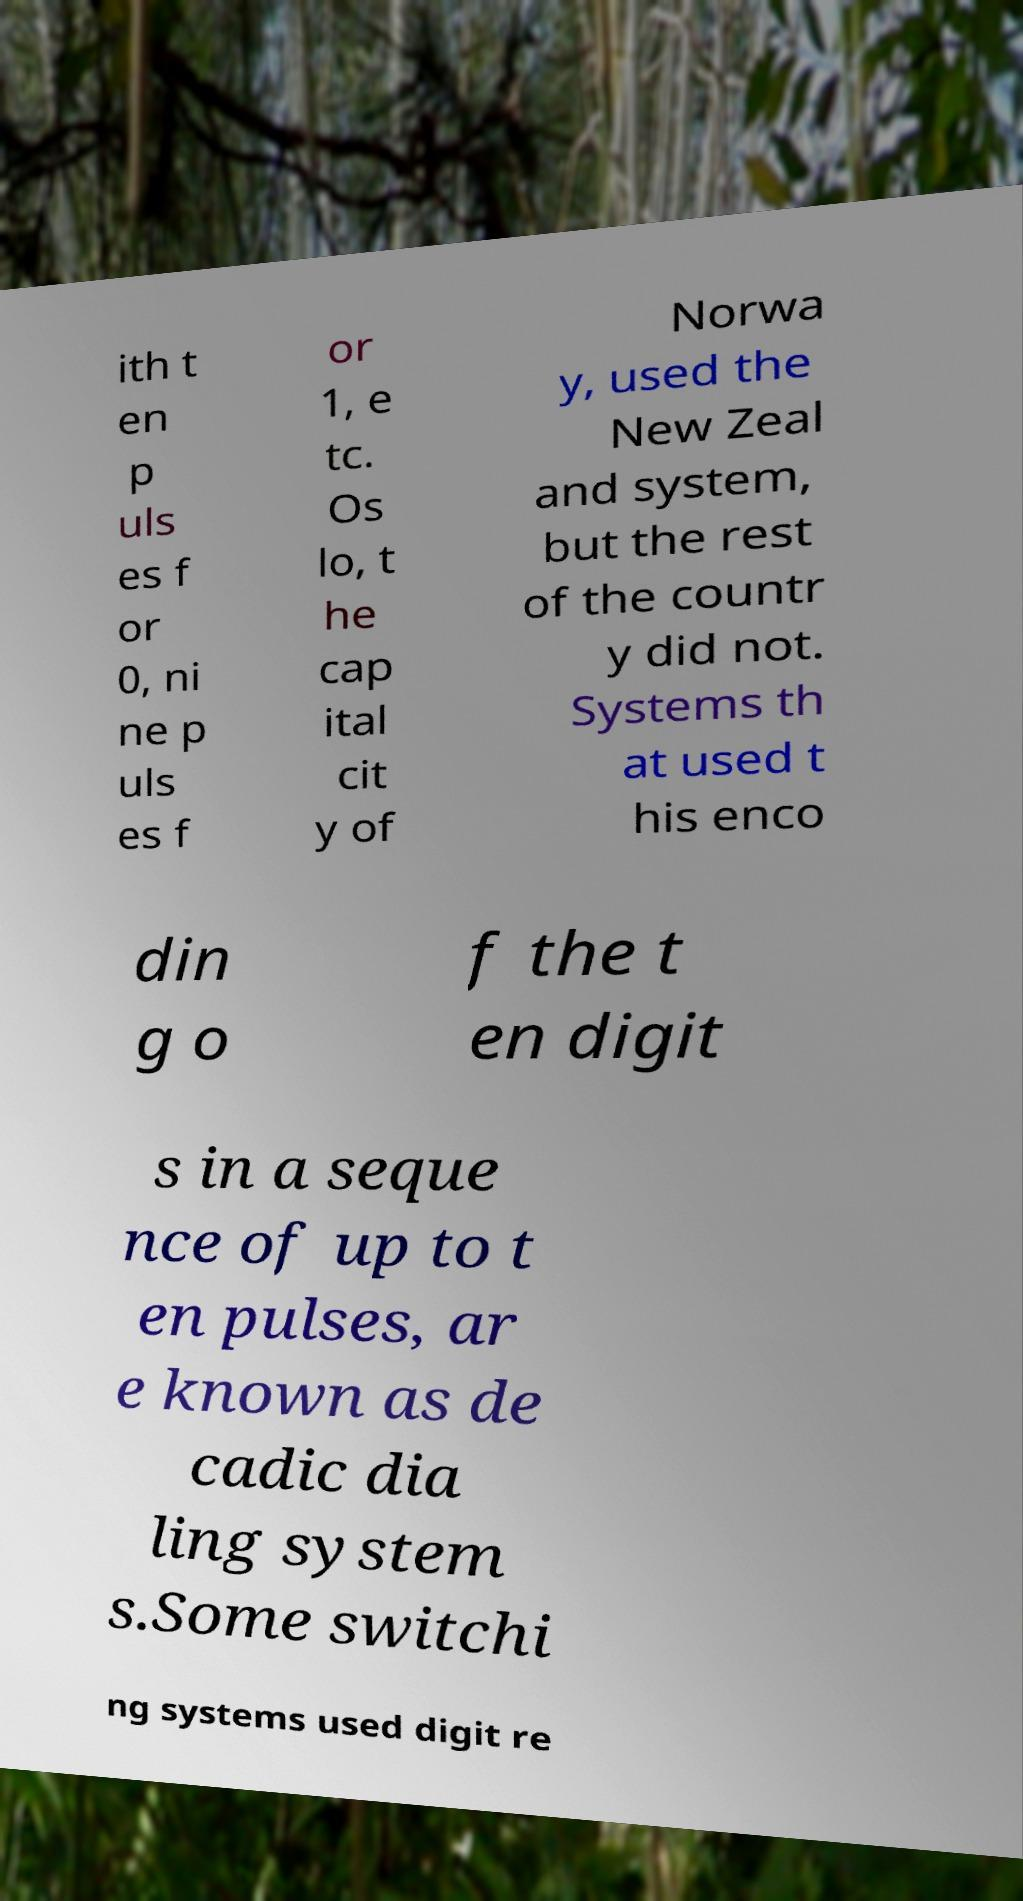For documentation purposes, I need the text within this image transcribed. Could you provide that? ith t en p uls es f or 0, ni ne p uls es f or 1, e tc. Os lo, t he cap ital cit y of Norwa y, used the New Zeal and system, but the rest of the countr y did not. Systems th at used t his enco din g o f the t en digit s in a seque nce of up to t en pulses, ar e known as de cadic dia ling system s.Some switchi ng systems used digit re 